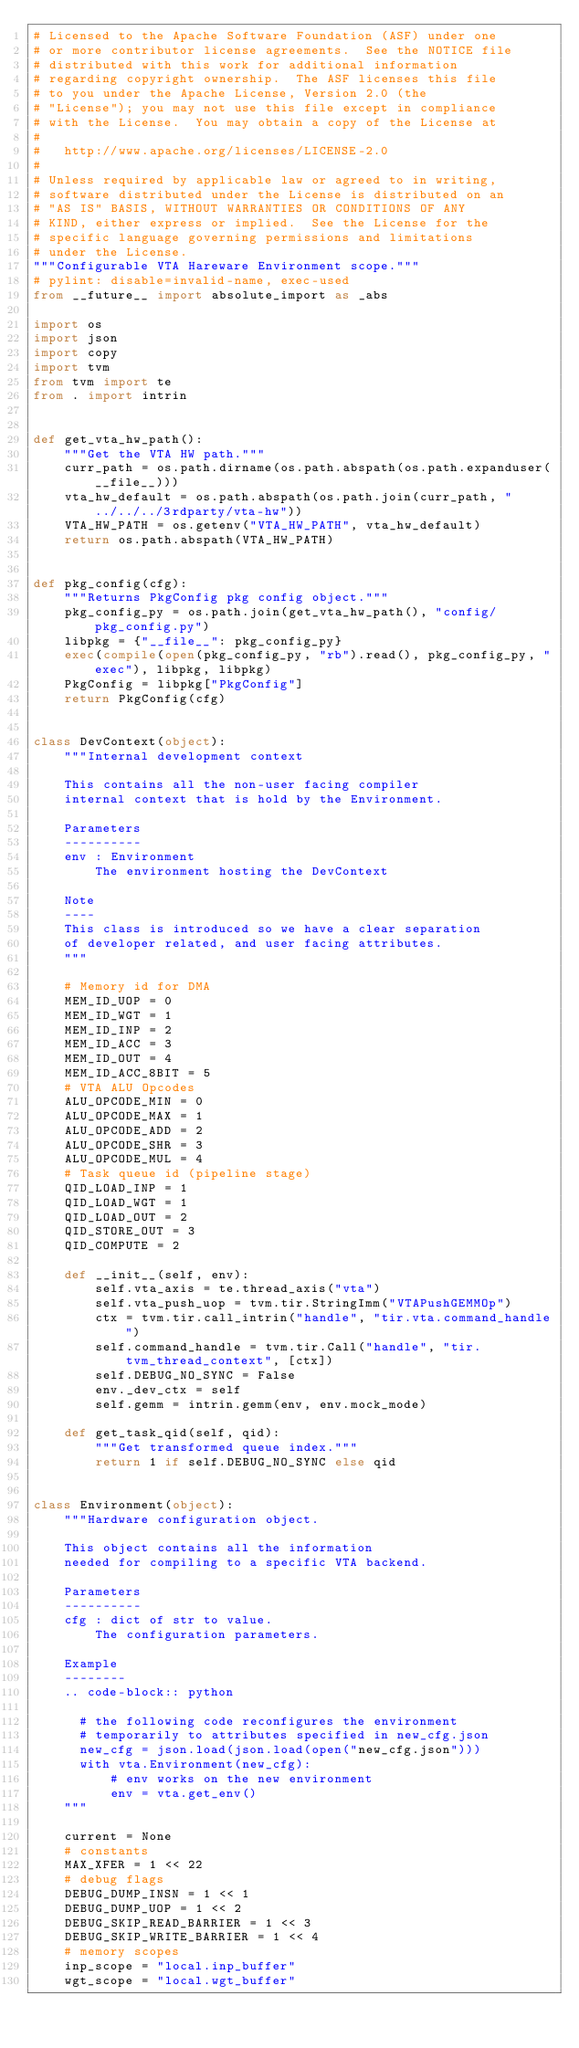Convert code to text. <code><loc_0><loc_0><loc_500><loc_500><_Python_># Licensed to the Apache Software Foundation (ASF) under one
# or more contributor license agreements.  See the NOTICE file
# distributed with this work for additional information
# regarding copyright ownership.  The ASF licenses this file
# to you under the Apache License, Version 2.0 (the
# "License"); you may not use this file except in compliance
# with the License.  You may obtain a copy of the License at
#
#   http://www.apache.org/licenses/LICENSE-2.0
#
# Unless required by applicable law or agreed to in writing,
# software distributed under the License is distributed on an
# "AS IS" BASIS, WITHOUT WARRANTIES OR CONDITIONS OF ANY
# KIND, either express or implied.  See the License for the
# specific language governing permissions and limitations
# under the License.
"""Configurable VTA Hareware Environment scope."""
# pylint: disable=invalid-name, exec-used
from __future__ import absolute_import as _abs

import os
import json
import copy
import tvm
from tvm import te
from . import intrin


def get_vta_hw_path():
    """Get the VTA HW path."""
    curr_path = os.path.dirname(os.path.abspath(os.path.expanduser(__file__)))
    vta_hw_default = os.path.abspath(os.path.join(curr_path, "../../../3rdparty/vta-hw"))
    VTA_HW_PATH = os.getenv("VTA_HW_PATH", vta_hw_default)
    return os.path.abspath(VTA_HW_PATH)


def pkg_config(cfg):
    """Returns PkgConfig pkg config object."""
    pkg_config_py = os.path.join(get_vta_hw_path(), "config/pkg_config.py")
    libpkg = {"__file__": pkg_config_py}
    exec(compile(open(pkg_config_py, "rb").read(), pkg_config_py, "exec"), libpkg, libpkg)
    PkgConfig = libpkg["PkgConfig"]
    return PkgConfig(cfg)


class DevContext(object):
    """Internal development context

    This contains all the non-user facing compiler
    internal context that is hold by the Environment.

    Parameters
    ----------
    env : Environment
        The environment hosting the DevContext

    Note
    ----
    This class is introduced so we have a clear separation
    of developer related, and user facing attributes.
    """

    # Memory id for DMA
    MEM_ID_UOP = 0
    MEM_ID_WGT = 1
    MEM_ID_INP = 2
    MEM_ID_ACC = 3
    MEM_ID_OUT = 4
    MEM_ID_ACC_8BIT = 5
    # VTA ALU Opcodes
    ALU_OPCODE_MIN = 0
    ALU_OPCODE_MAX = 1
    ALU_OPCODE_ADD = 2
    ALU_OPCODE_SHR = 3
    ALU_OPCODE_MUL = 4
    # Task queue id (pipeline stage)
    QID_LOAD_INP = 1
    QID_LOAD_WGT = 1
    QID_LOAD_OUT = 2
    QID_STORE_OUT = 3
    QID_COMPUTE = 2

    def __init__(self, env):
        self.vta_axis = te.thread_axis("vta")
        self.vta_push_uop = tvm.tir.StringImm("VTAPushGEMMOp")
        ctx = tvm.tir.call_intrin("handle", "tir.vta.command_handle")
        self.command_handle = tvm.tir.Call("handle", "tir.tvm_thread_context", [ctx])
        self.DEBUG_NO_SYNC = False
        env._dev_ctx = self
        self.gemm = intrin.gemm(env, env.mock_mode)

    def get_task_qid(self, qid):
        """Get transformed queue index."""
        return 1 if self.DEBUG_NO_SYNC else qid


class Environment(object):
    """Hardware configuration object.

    This object contains all the information
    needed for compiling to a specific VTA backend.

    Parameters
    ----------
    cfg : dict of str to value.
        The configuration parameters.

    Example
    --------
    .. code-block:: python

      # the following code reconfigures the environment
      # temporarily to attributes specified in new_cfg.json
      new_cfg = json.load(json.load(open("new_cfg.json")))
      with vta.Environment(new_cfg):
          # env works on the new environment
          env = vta.get_env()
    """

    current = None
    # constants
    MAX_XFER = 1 << 22
    # debug flags
    DEBUG_DUMP_INSN = 1 << 1
    DEBUG_DUMP_UOP = 1 << 2
    DEBUG_SKIP_READ_BARRIER = 1 << 3
    DEBUG_SKIP_WRITE_BARRIER = 1 << 4
    # memory scopes
    inp_scope = "local.inp_buffer"
    wgt_scope = "local.wgt_buffer"</code> 